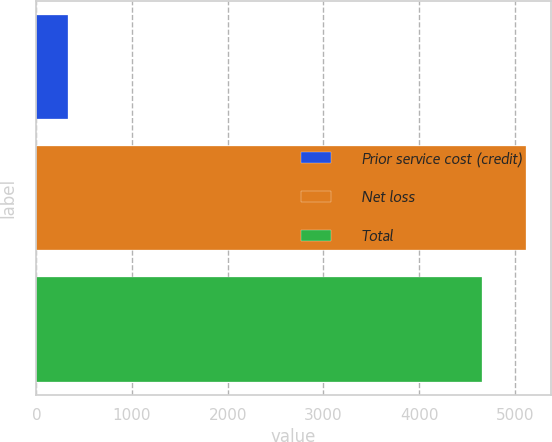Convert chart to OTSL. <chart><loc_0><loc_0><loc_500><loc_500><bar_chart><fcel>Prior service cost (credit)<fcel>Net loss<fcel>Total<nl><fcel>329<fcel>5120.5<fcel>4655<nl></chart> 